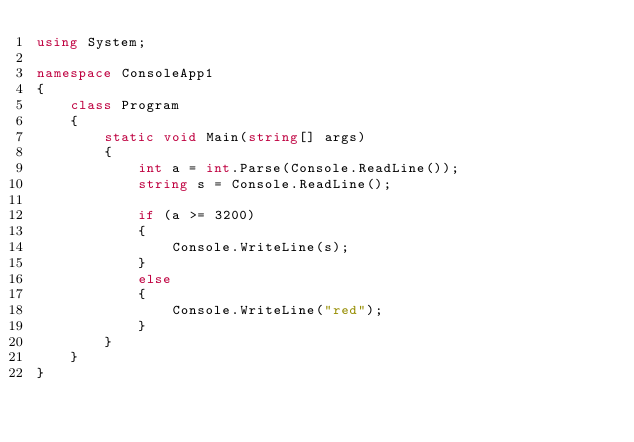<code> <loc_0><loc_0><loc_500><loc_500><_C#_>using System;

namespace ConsoleApp1
{
	class Program
	{
		static void Main(string[] args)
		{
			int a = int.Parse(Console.ReadLine());
			string s = Console.ReadLine();

			if (a >= 3200)
			{
				Console.WriteLine(s);
			}
			else
			{
				Console.WriteLine("red");
			}
		}
	}
}
</code> 